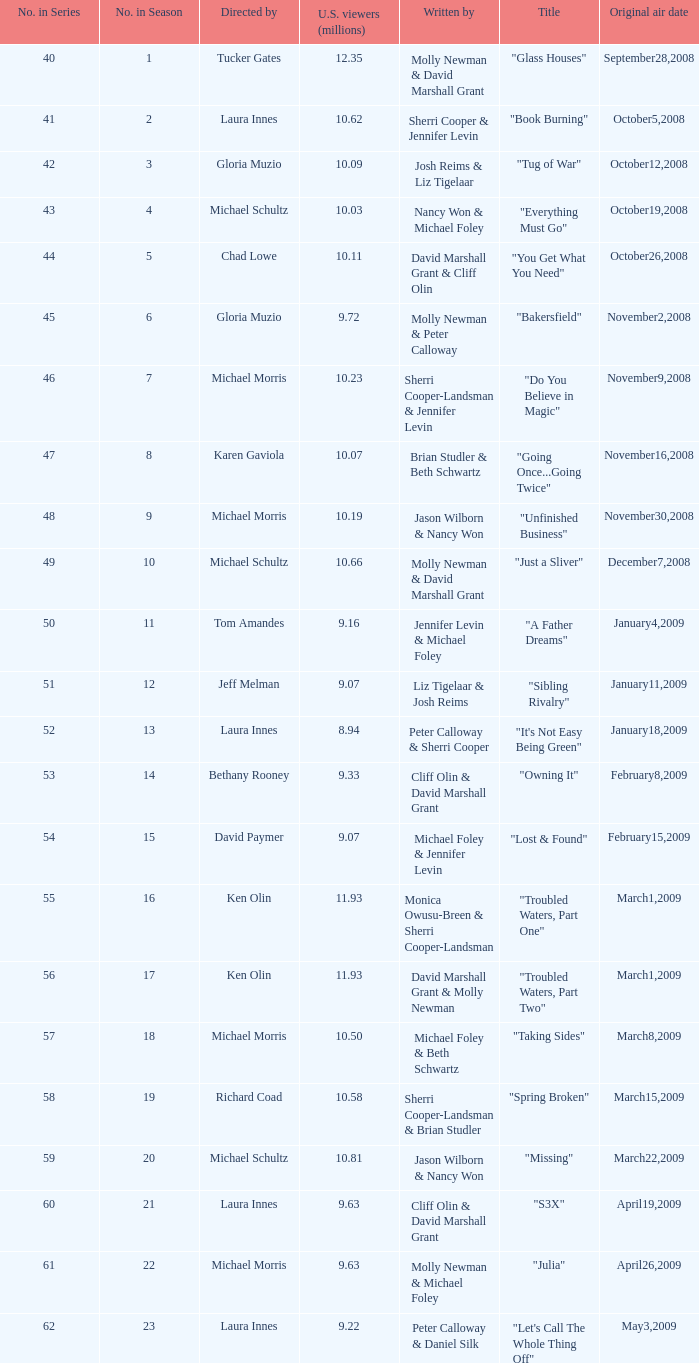Who wrote the episode whose director is Karen Gaviola? Brian Studler & Beth Schwartz. 